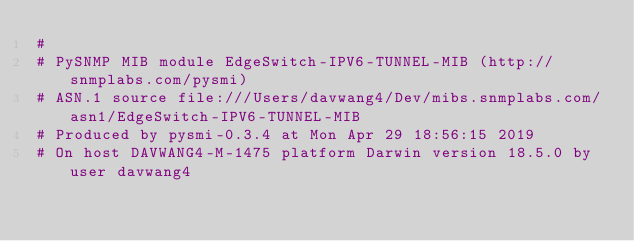Convert code to text. <code><loc_0><loc_0><loc_500><loc_500><_Python_>#
# PySNMP MIB module EdgeSwitch-IPV6-TUNNEL-MIB (http://snmplabs.com/pysmi)
# ASN.1 source file:///Users/davwang4/Dev/mibs.snmplabs.com/asn1/EdgeSwitch-IPV6-TUNNEL-MIB
# Produced by pysmi-0.3.4 at Mon Apr 29 18:56:15 2019
# On host DAVWANG4-M-1475 platform Darwin version 18.5.0 by user davwang4</code> 